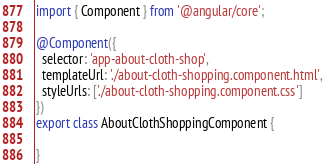Convert code to text. <code><loc_0><loc_0><loc_500><loc_500><_TypeScript_>import { Component } from '@angular/core';

@Component({
  selector: 'app-about-cloth-shop',
  templateUrl: './about-cloth-shopping.component.html',
  styleUrls: ['./about-cloth-shopping.component.css']
})
export class AboutClothShoppingComponent {

}</code> 